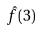<formula> <loc_0><loc_0><loc_500><loc_500>\hat { f } ( 3 )</formula> 